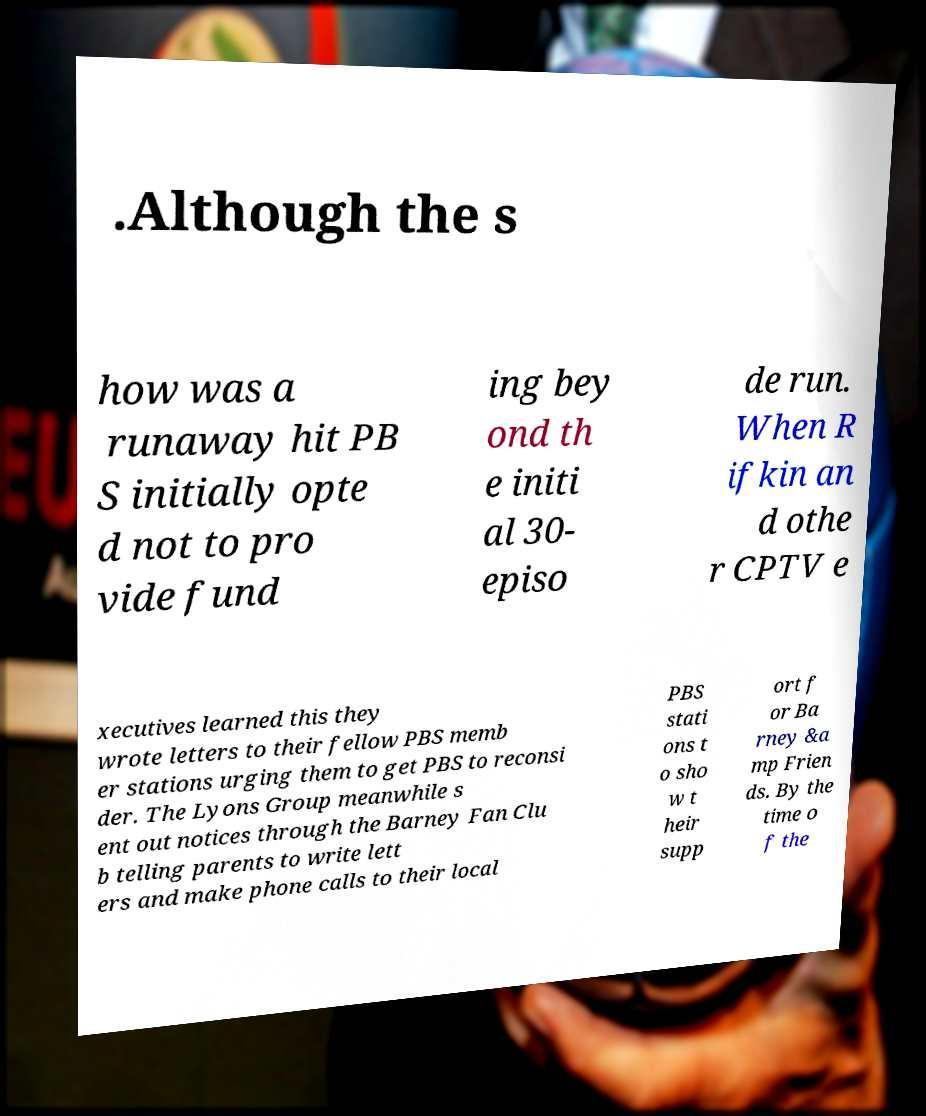Can you read and provide the text displayed in the image?This photo seems to have some interesting text. Can you extract and type it out for me? .Although the s how was a runaway hit PB S initially opte d not to pro vide fund ing bey ond th e initi al 30- episo de run. When R ifkin an d othe r CPTV e xecutives learned this they wrote letters to their fellow PBS memb er stations urging them to get PBS to reconsi der. The Lyons Group meanwhile s ent out notices through the Barney Fan Clu b telling parents to write lett ers and make phone calls to their local PBS stati ons t o sho w t heir supp ort f or Ba rney &a mp Frien ds. By the time o f the 